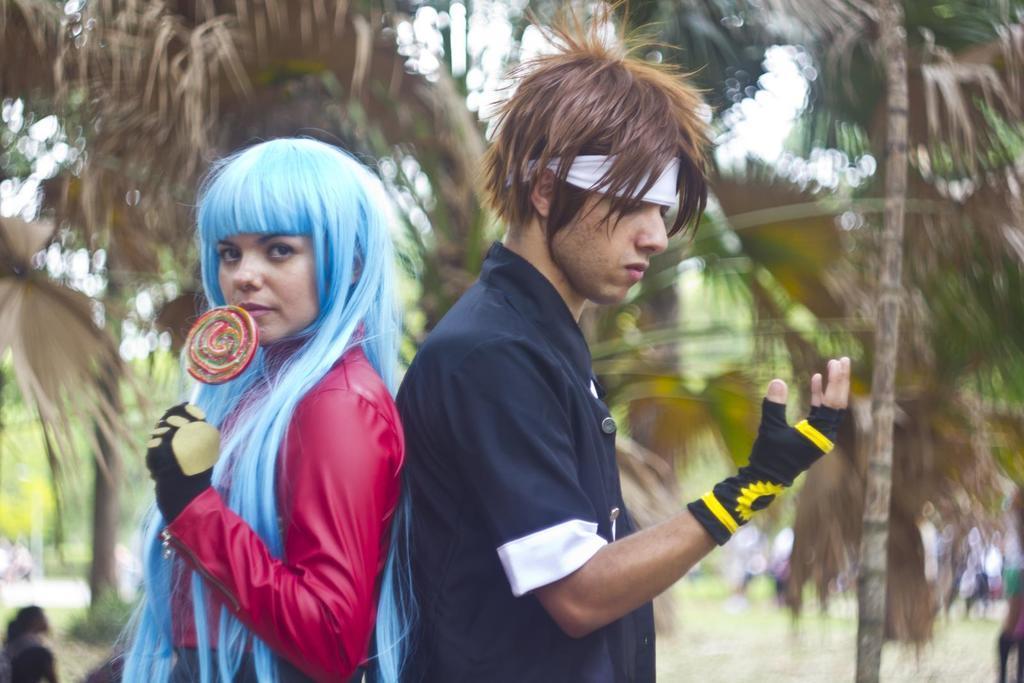Please provide a concise description of this image. In this picture we can see a man and a woman are standing, this woman is holding a lollipop, in the background we can see trees and some people, there is a blurry background. 